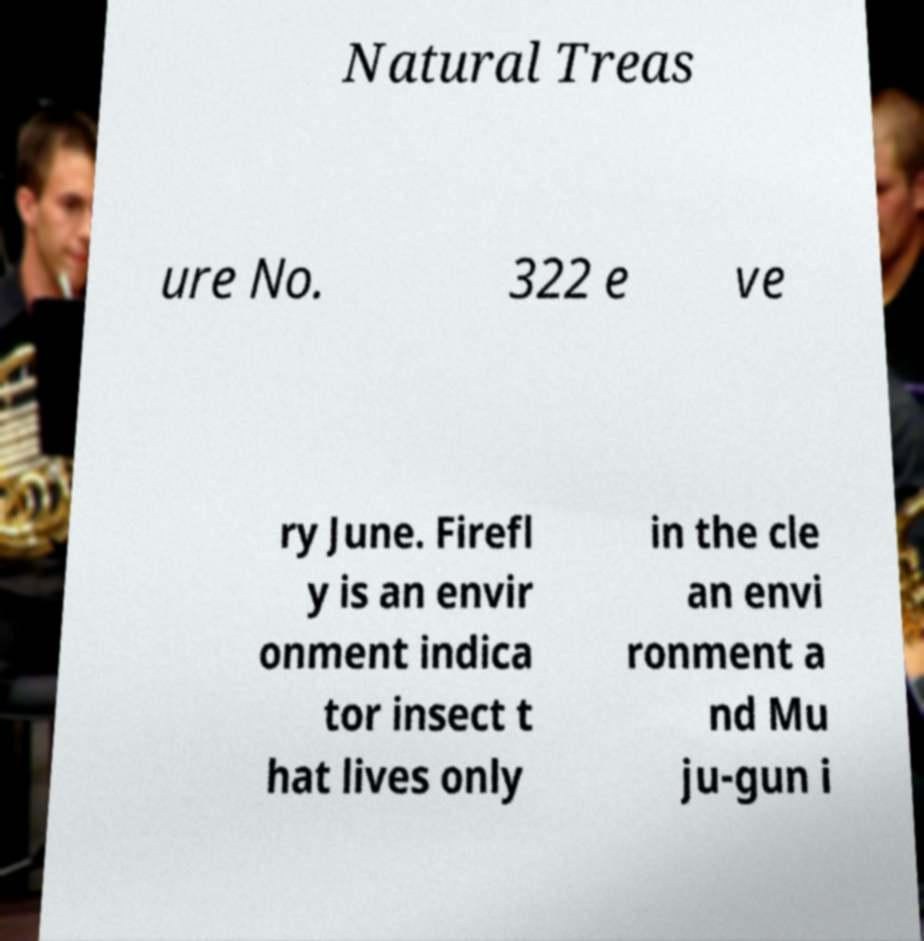For documentation purposes, I need the text within this image transcribed. Could you provide that? Natural Treas ure No. 322 e ve ry June. Firefl y is an envir onment indica tor insect t hat lives only in the cle an envi ronment a nd Mu ju-gun i 